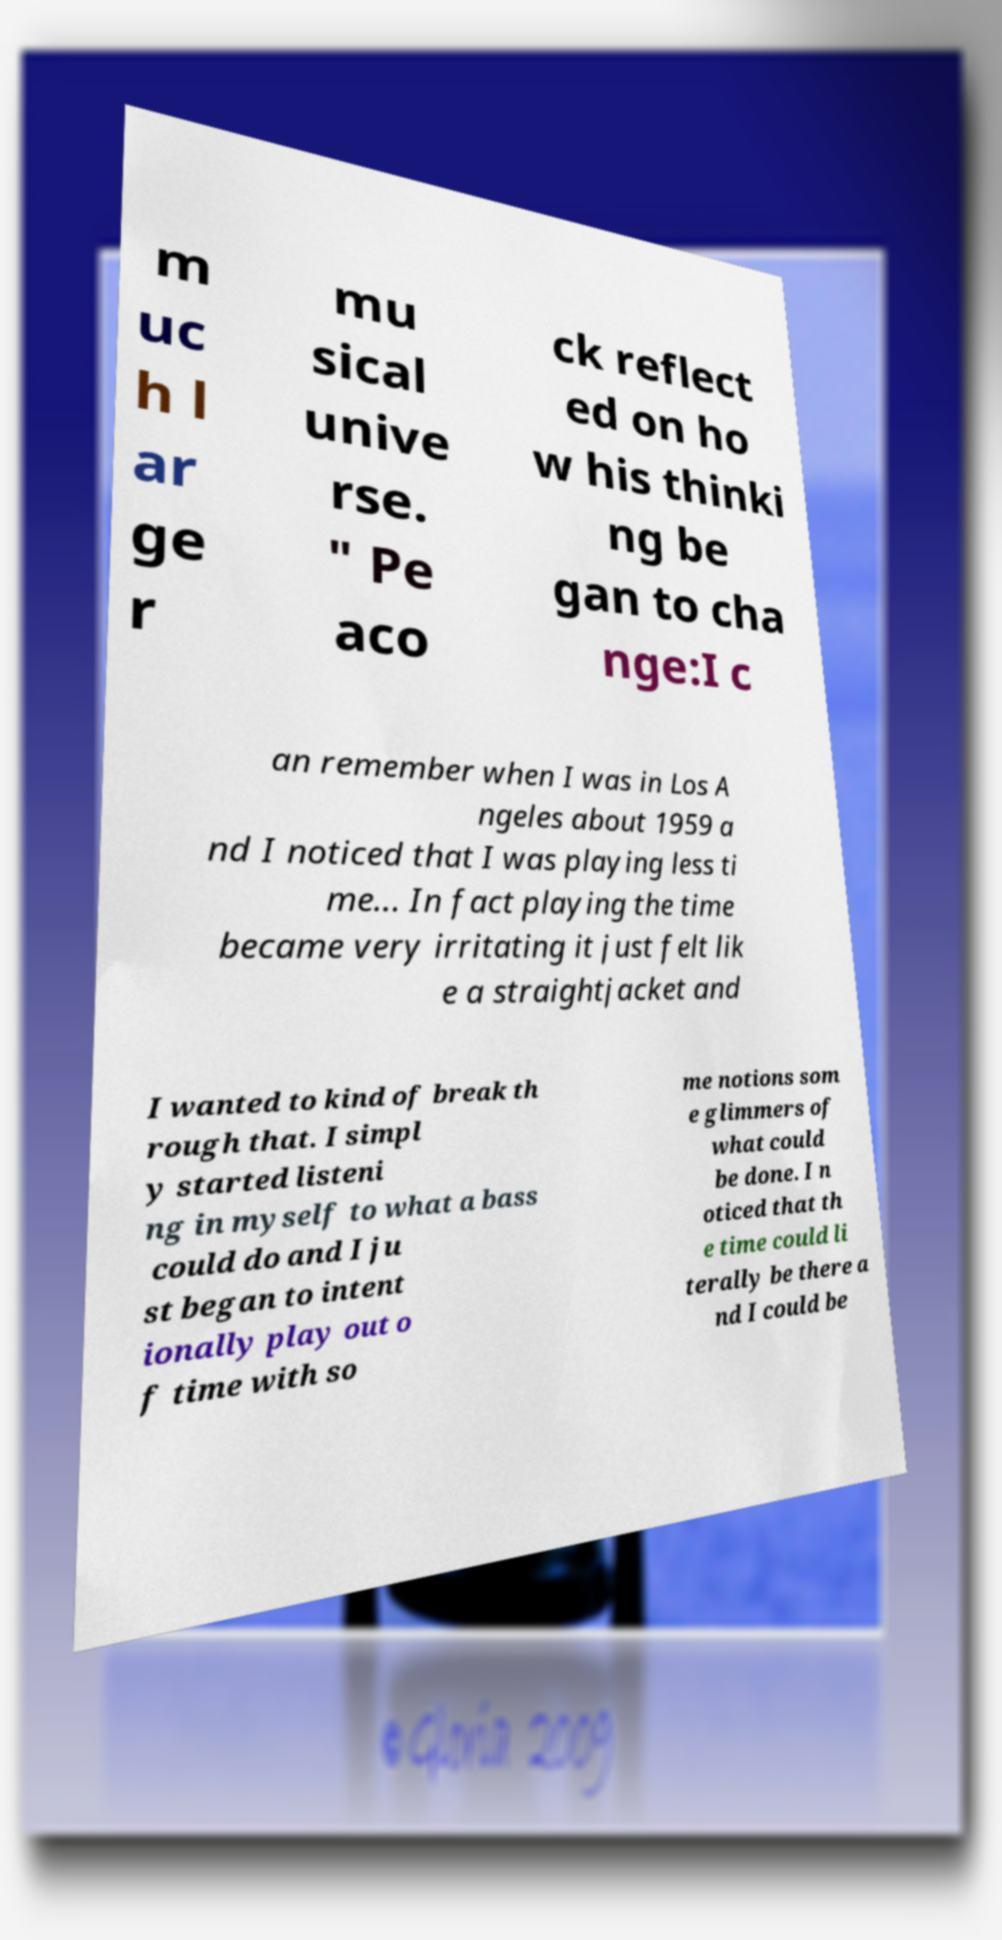Could you extract and type out the text from this image? m uc h l ar ge r mu sical unive rse. " Pe aco ck reflect ed on ho w his thinki ng be gan to cha nge:I c an remember when I was in Los A ngeles about 1959 a nd I noticed that I was playing less ti me... In fact playing the time became very irritating it just felt lik e a straightjacket and I wanted to kind of break th rough that. I simpl y started listeni ng in myself to what a bass could do and I ju st began to intent ionally play out o f time with so me notions som e glimmers of what could be done. I n oticed that th e time could li terally be there a nd I could be 